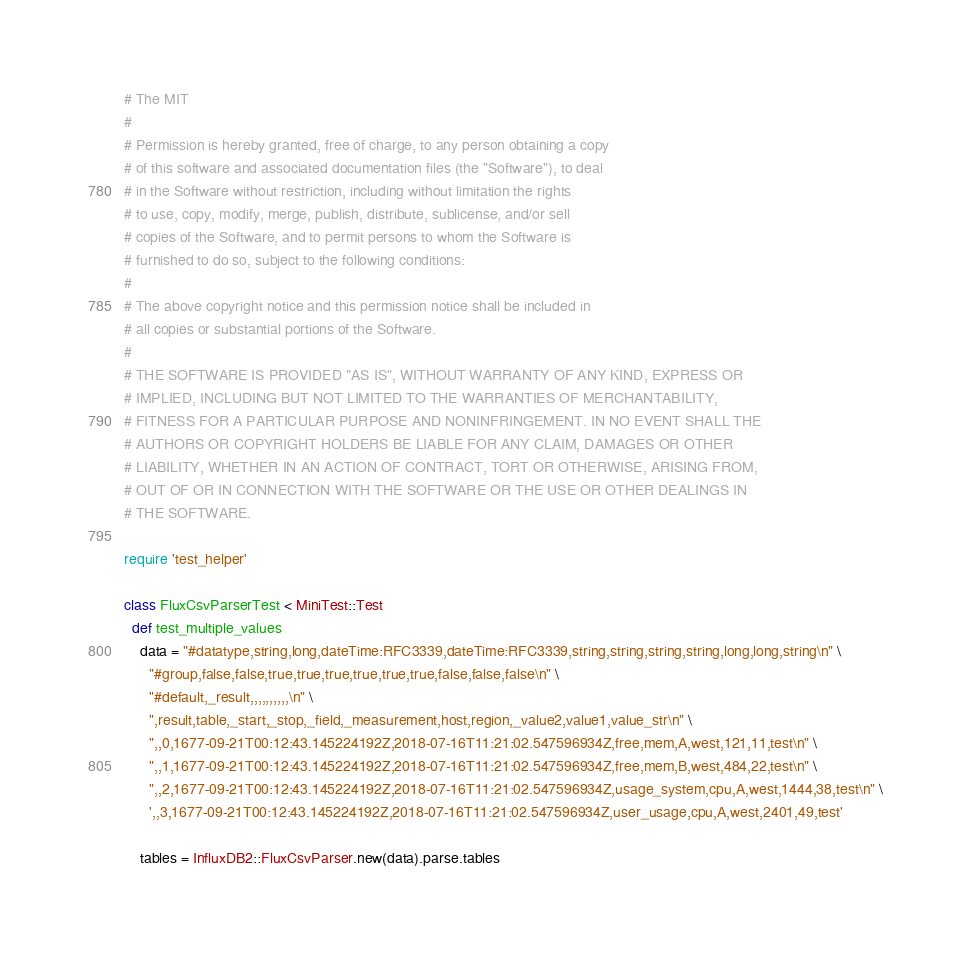Convert code to text. <code><loc_0><loc_0><loc_500><loc_500><_Ruby_># The MIT
#
# Permission is hereby granted, free of charge, to any person obtaining a copy
# of this software and associated documentation files (the "Software"), to deal
# in the Software without restriction, including without limitation the rights
# to use, copy, modify, merge, publish, distribute, sublicense, and/or sell
# copies of the Software, and to permit persons to whom the Software is
# furnished to do so, subject to the following conditions:
#
# The above copyright notice and this permission notice shall be included in
# all copies or substantial portions of the Software.
#
# THE SOFTWARE IS PROVIDED "AS IS", WITHOUT WARRANTY OF ANY KIND, EXPRESS OR
# IMPLIED, INCLUDING BUT NOT LIMITED TO THE WARRANTIES OF MERCHANTABILITY,
# FITNESS FOR A PARTICULAR PURPOSE AND NONINFRINGEMENT. IN NO EVENT SHALL THE
# AUTHORS OR COPYRIGHT HOLDERS BE LIABLE FOR ANY CLAIM, DAMAGES OR OTHER
# LIABILITY, WHETHER IN AN ACTION OF CONTRACT, TORT OR OTHERWISE, ARISING FROM,
# OUT OF OR IN CONNECTION WITH THE SOFTWARE OR THE USE OR OTHER DEALINGS IN
# THE SOFTWARE.

require 'test_helper'

class FluxCsvParserTest < MiniTest::Test
  def test_multiple_values
    data = "#datatype,string,long,dateTime:RFC3339,dateTime:RFC3339,string,string,string,string,long,long,string\n" \
      "#group,false,false,true,true,true,true,true,true,false,false,false\n" \
      "#default,_result,,,,,,,,,,\n" \
      ",result,table,_start,_stop,_field,_measurement,host,region,_value2,value1,value_str\n" \
      ",,0,1677-09-21T00:12:43.145224192Z,2018-07-16T11:21:02.547596934Z,free,mem,A,west,121,11,test\n" \
      ",,1,1677-09-21T00:12:43.145224192Z,2018-07-16T11:21:02.547596934Z,free,mem,B,west,484,22,test\n" \
      ",,2,1677-09-21T00:12:43.145224192Z,2018-07-16T11:21:02.547596934Z,usage_system,cpu,A,west,1444,38,test\n" \
      ',,3,1677-09-21T00:12:43.145224192Z,2018-07-16T11:21:02.547596934Z,user_usage,cpu,A,west,2401,49,test'

    tables = InfluxDB2::FluxCsvParser.new(data).parse.tables
</code> 